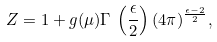Convert formula to latex. <formula><loc_0><loc_0><loc_500><loc_500>Z = 1 + g ( \mu ) \Gamma \, \left ( \frac { \epsilon } { 2 } \right ) ( 4 \pi ) ^ { \frac { \epsilon - 2 } { 2 } } ,</formula> 